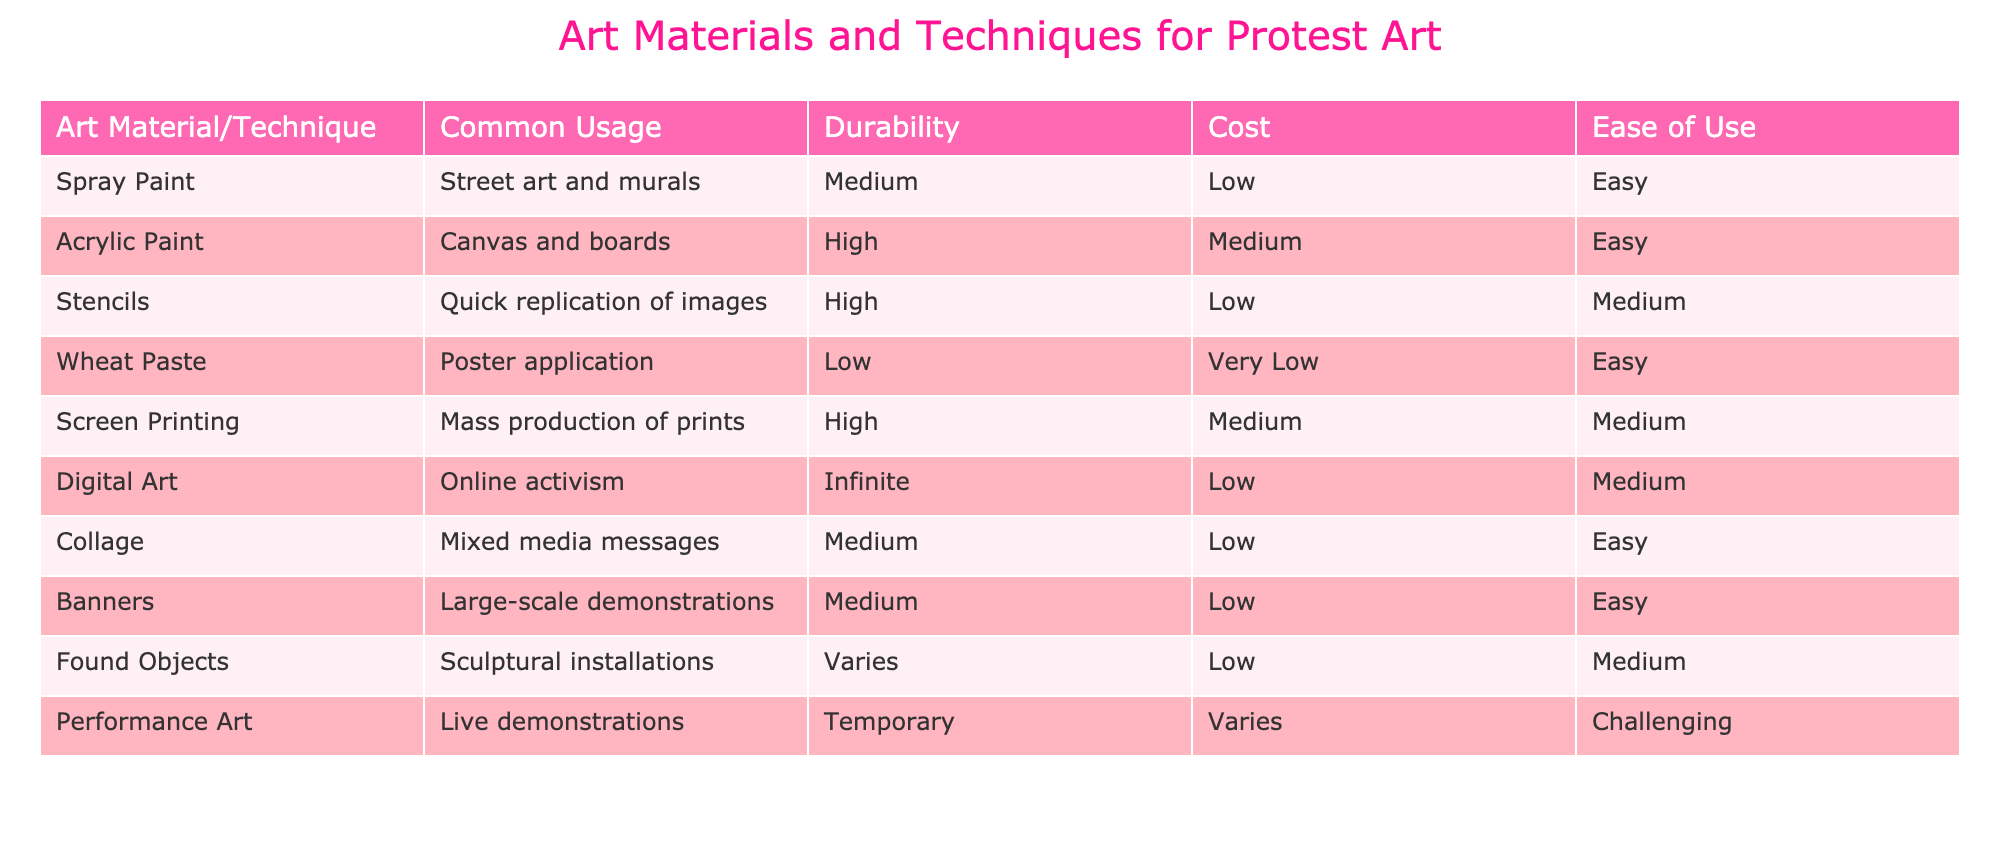What is the most commonly used art material for street art? The table shows that spray paint is used for street art and murals. It is listed under the "Common Usage" column for the "Spray Paint" row.
Answer: Spray Paint Which technique has the lowest durability? Looking at the "Durability" column, wheat paste has the lowest rating of "Low." This is confirmed by checking which materials have a distinct lower durability designation.
Answer: Wheat Paste How many art materials have a high durability rating? The table lists three materials with a "High" durability: Acrylic Paint, Stencils, and Screen Printing. Adding those up gives us the answer.
Answer: 3 Is digital art typically high in cost compared to other materials? Checking the "Cost" column, digital art is rated "Low" in cost, which means it is not high compared to other materials.
Answer: No What material or technique is easy to use but has a medium durability? The table indicates that both Collage and Banners are easy to use and have a medium durability rating. These materials can be combined in the answer due to their shared characteristics.
Answer: Collage, Banners Which two techniques can be used for mass production of art? The techniques for mass production listed in the table are Screen Printing and Digital Art. Both have specific usages that support mass production, thereby confirming their applicability.
Answer: Screen Printing, Digital Art Which art material is the most expensive, considering the cost ratings? The table does not provide a material with a "High" cost; instead, the cost ratings go from "Low" to "Medium." The highest cost designation appears to be "Medium," so there’s no specific material that can be identified as the most expensive. Therefore, a material with the highest cost can be classified as Screen Printing, Stencils, or Acrylic Paint.
Answer: Screen Printing, Stencils, Acrylic Paint If I want to create a temporary performance, which technique should I choose based on this table? The table indicates that Performance Art is designed for live demonstrations and has a "Temporary" durability designation, making it suitable for creating temporary performances.
Answer: Performance Art How many materials have both low cost and easy to use ratings? The table shows that there are four materials with both a "Low" cost and "Easy" to use rating: Spray Paint, Wheat Paste, Banners, and Collage. Counting these confirms the total.
Answer: 4 